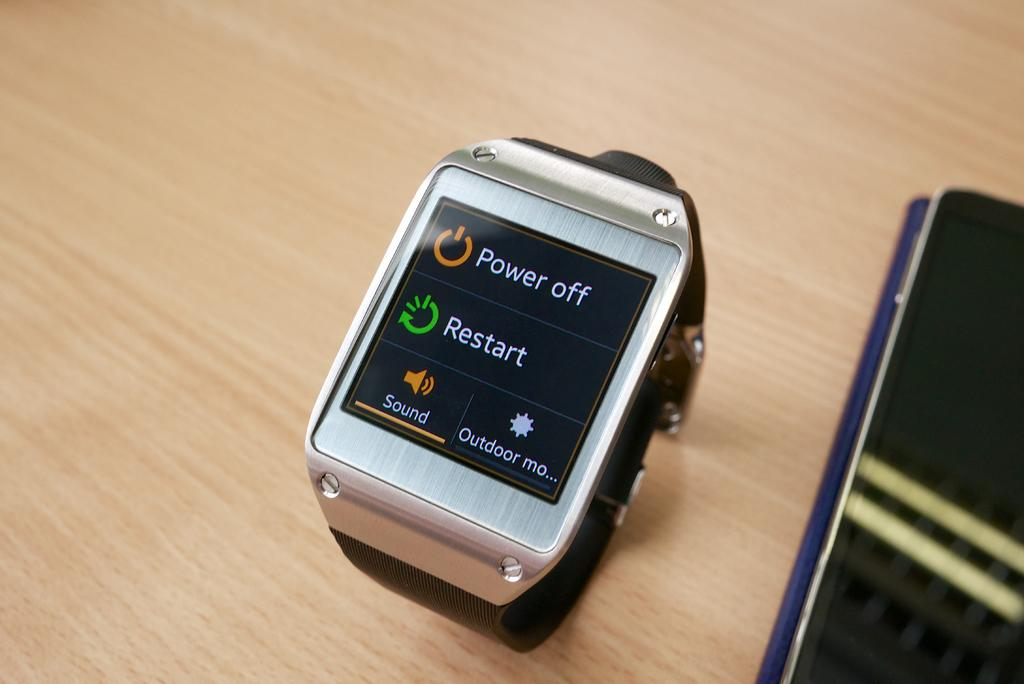<image>
Write a terse but informative summary of the picture. A watch screen's display has options to power off and restart. 